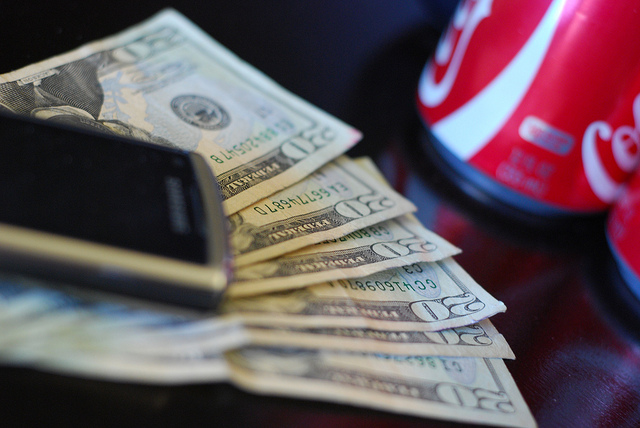Identify the text displayed in this image. 20 20 20 cO 20 20 20 0041609870 03 20 CBB EA667746870 